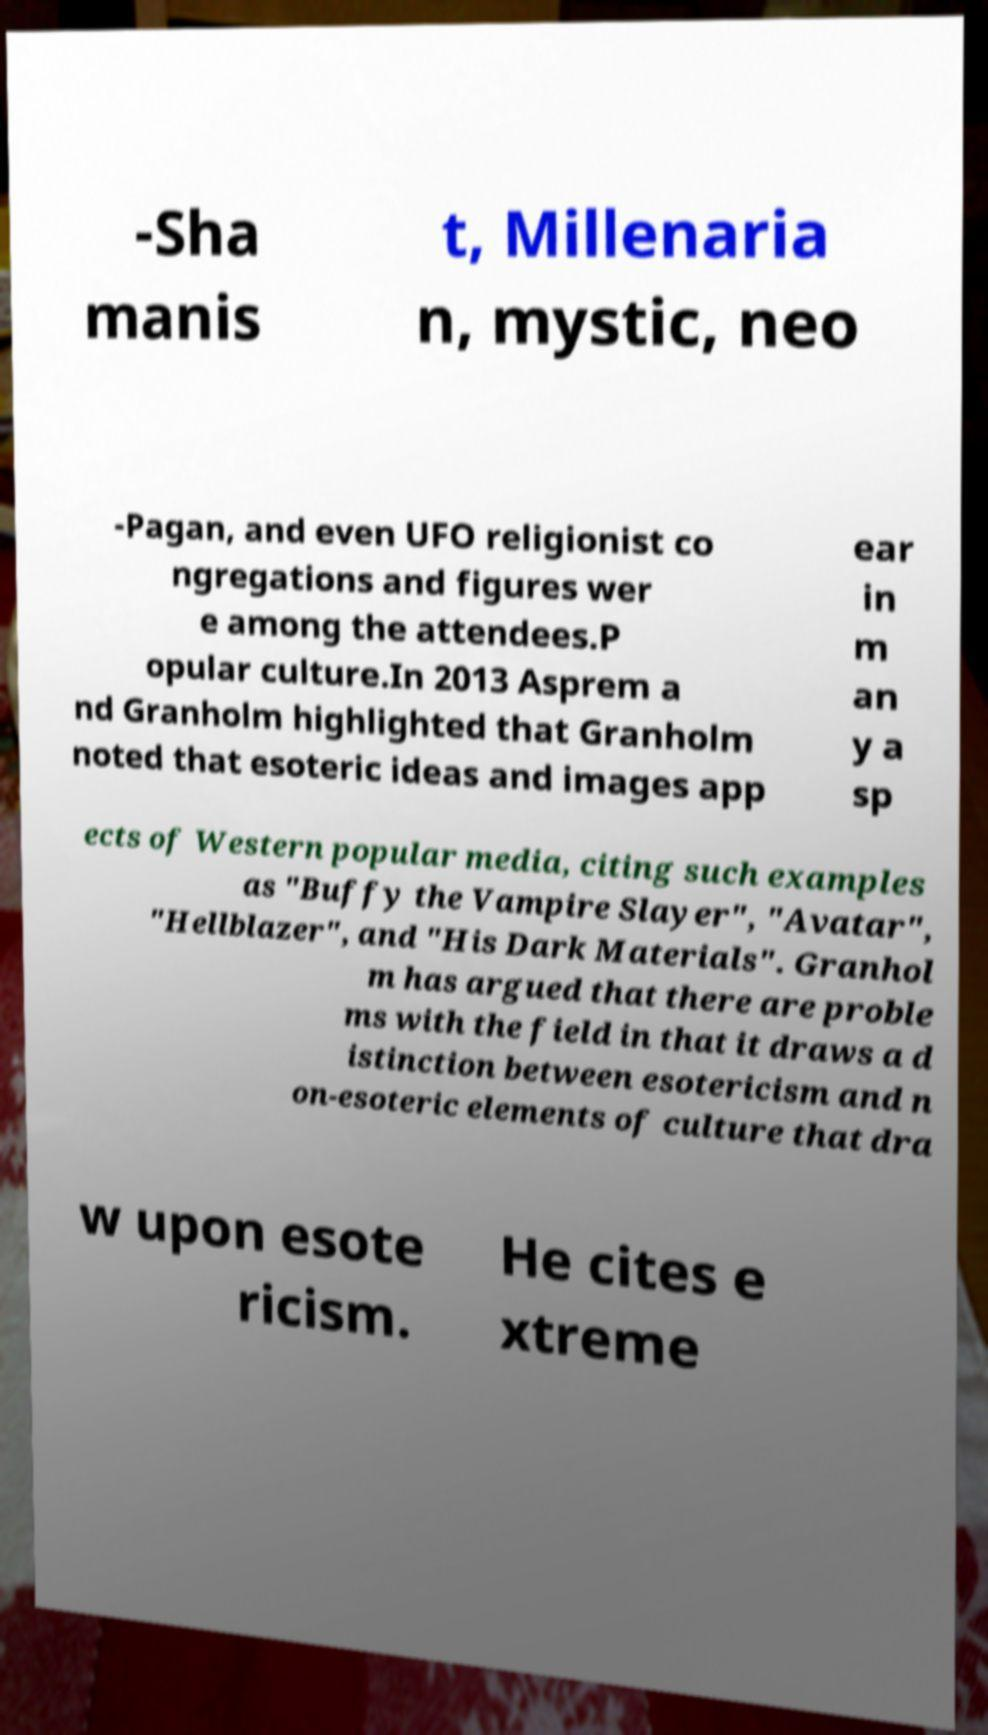Could you assist in decoding the text presented in this image and type it out clearly? -Sha manis t, Millenaria n, mystic, neo -Pagan, and even UFO religionist co ngregations and figures wer e among the attendees.P opular culture.In 2013 Asprem a nd Granholm highlighted that Granholm noted that esoteric ideas and images app ear in m an y a sp ects of Western popular media, citing such examples as "Buffy the Vampire Slayer", "Avatar", "Hellblazer", and "His Dark Materials". Granhol m has argued that there are proble ms with the field in that it draws a d istinction between esotericism and n on-esoteric elements of culture that dra w upon esote ricism. He cites e xtreme 